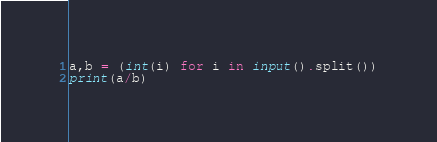Convert code to text. <code><loc_0><loc_0><loc_500><loc_500><_Python_>a,b = (int(i) for i in input().split())
print(a/b)</code> 